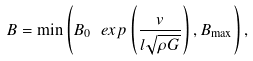<formula> <loc_0><loc_0><loc_500><loc_500>B = \min \left ( B _ { 0 } \ e x p \left ( \frac { v } { l \sqrt { \rho G } } \right ) , B _ { \max } \right ) ,</formula> 